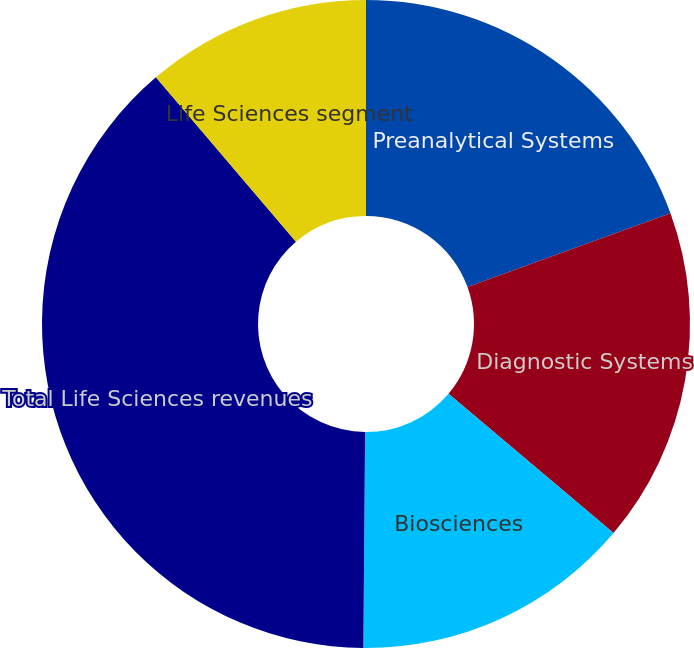Convert chart to OTSL. <chart><loc_0><loc_0><loc_500><loc_500><pie_chart><fcel>Preanalytical Systems<fcel>Diagnostic Systems<fcel>Biosciences<fcel>Total Life Sciences revenues<fcel>Life Sciences segment<nl><fcel>19.45%<fcel>16.71%<fcel>13.97%<fcel>38.64%<fcel>11.23%<nl></chart> 